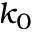Convert formula to latex. <formula><loc_0><loc_0><loc_500><loc_500>k _ { 0 }</formula> 